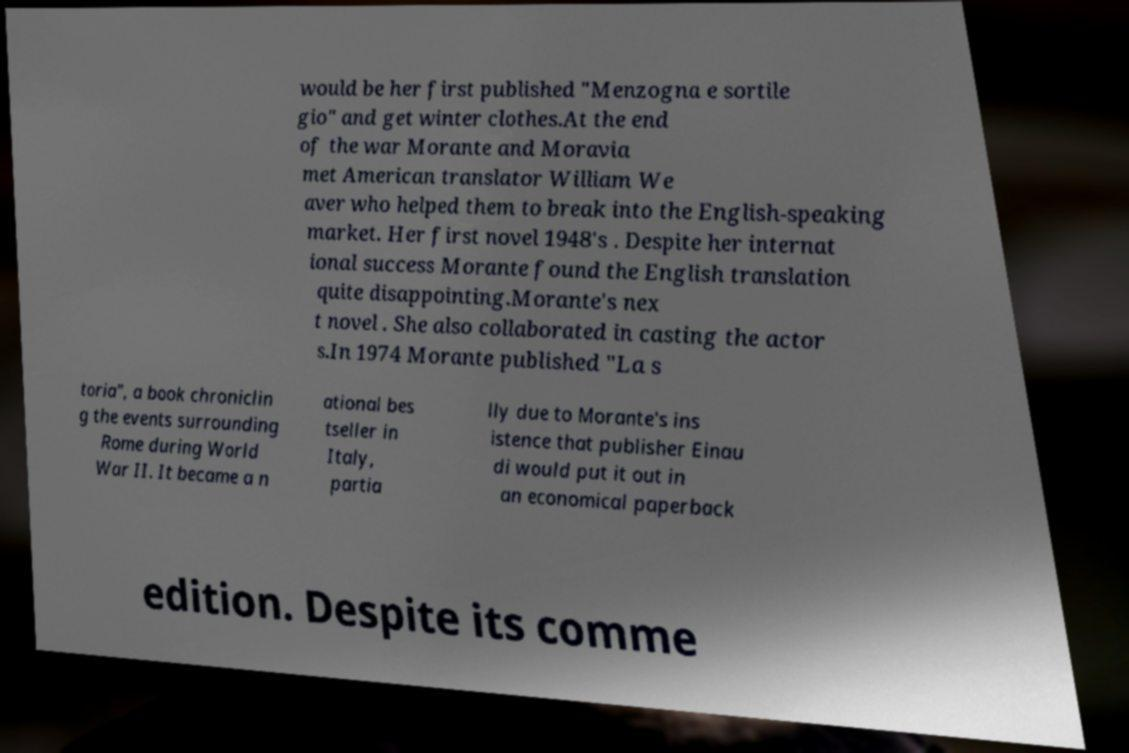What messages or text are displayed in this image? I need them in a readable, typed format. would be her first published "Menzogna e sortile gio" and get winter clothes.At the end of the war Morante and Moravia met American translator William We aver who helped them to break into the English-speaking market. Her first novel 1948's . Despite her internat ional success Morante found the English translation quite disappointing.Morante's nex t novel . She also collaborated in casting the actor s.In 1974 Morante published "La s toria", a book chroniclin g the events surrounding Rome during World War II. It became a n ational bes tseller in Italy, partia lly due to Morante's ins istence that publisher Einau di would put it out in an economical paperback edition. Despite its comme 